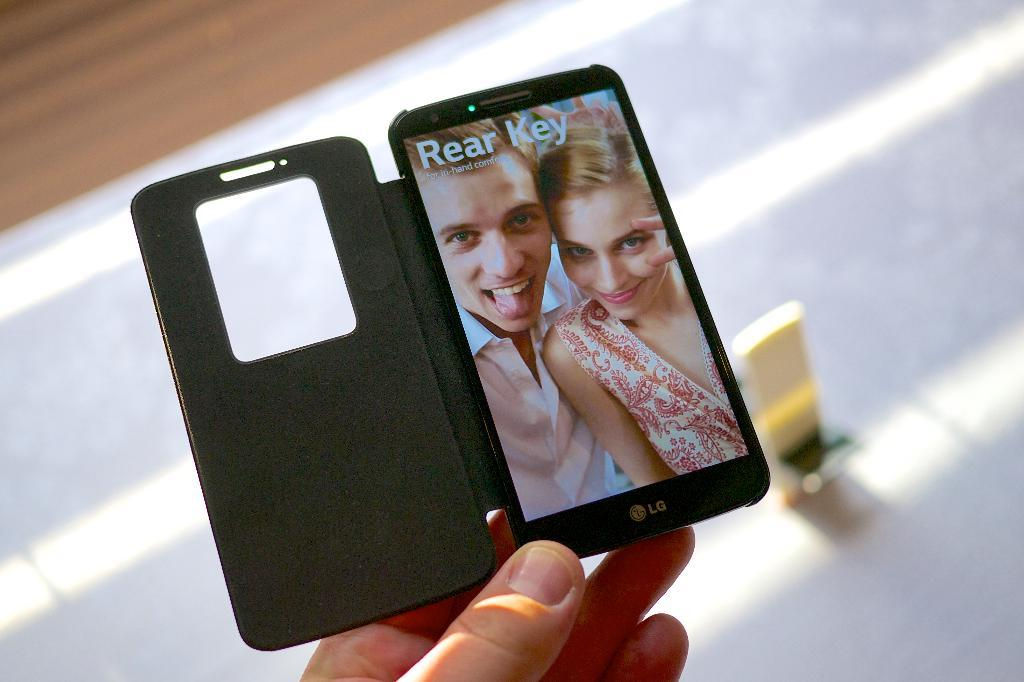<image>
Summarize the visual content of the image. handing holding a phone that has a picture of a couple posing and the words rear key at the top 